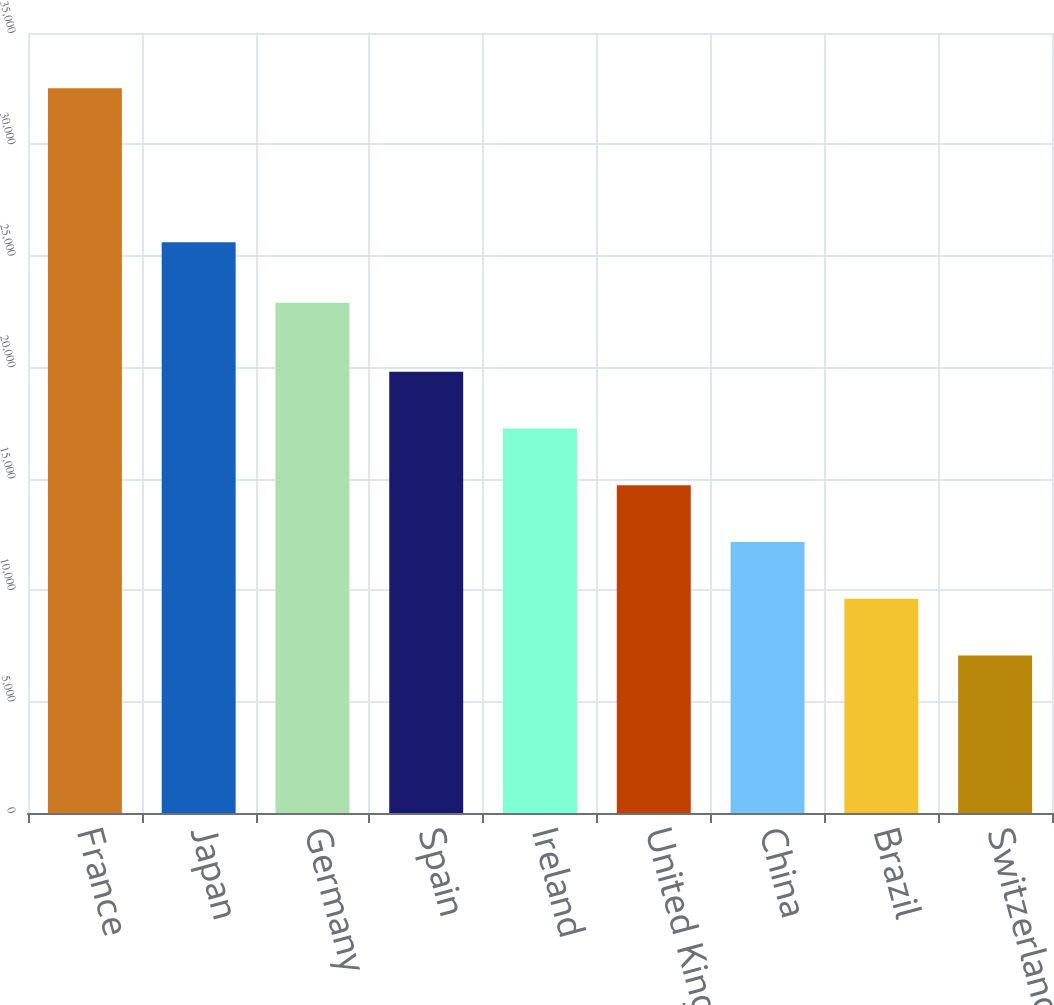Convert chart. <chart><loc_0><loc_0><loc_500><loc_500><bar_chart><fcel>France<fcel>Japan<fcel>Germany<fcel>Spain<fcel>Ireland<fcel>United Kingdom<fcel>China<fcel>Brazil<fcel>Switzerland<nl><fcel>32522<fcel>25606<fcel>22900<fcel>19795.5<fcel>17250.2<fcel>14704.9<fcel>12159.6<fcel>9614.3<fcel>7069<nl></chart> 